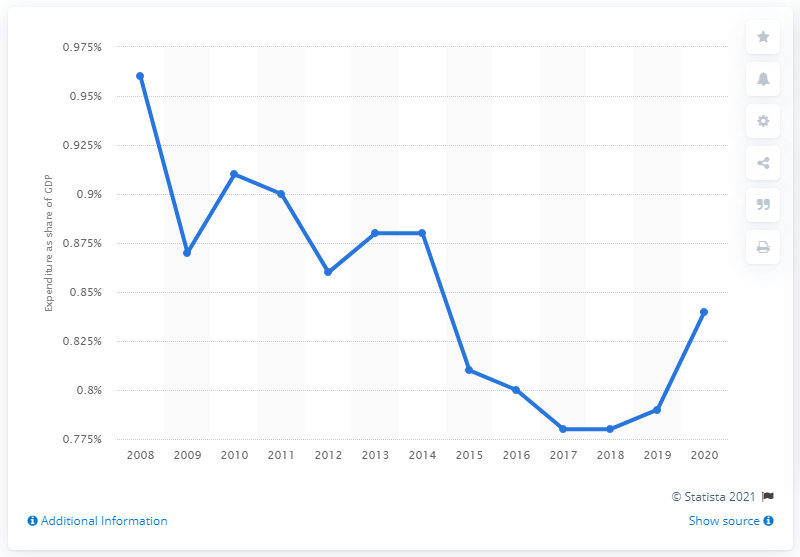Indicate a few pertinent items in this graphic. In 2008, the expenditure on defense represented 0.96% of the Gross Domestic Product (GDP). During the period of 2008 to 2020, approximately 8.4% of Italy's Gross Domestic Product (GDP) was allocated towards defense spending. 